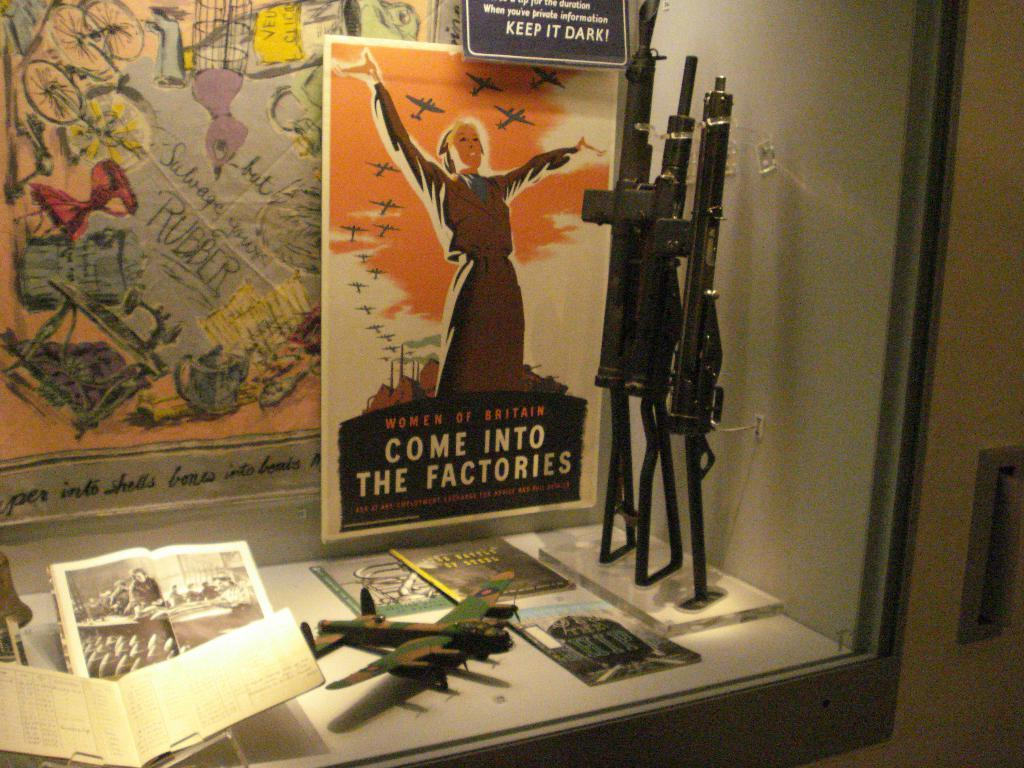<image>
Offer a succinct explanation of the picture presented. A display of military items which a poster that says "Come into the factories" 